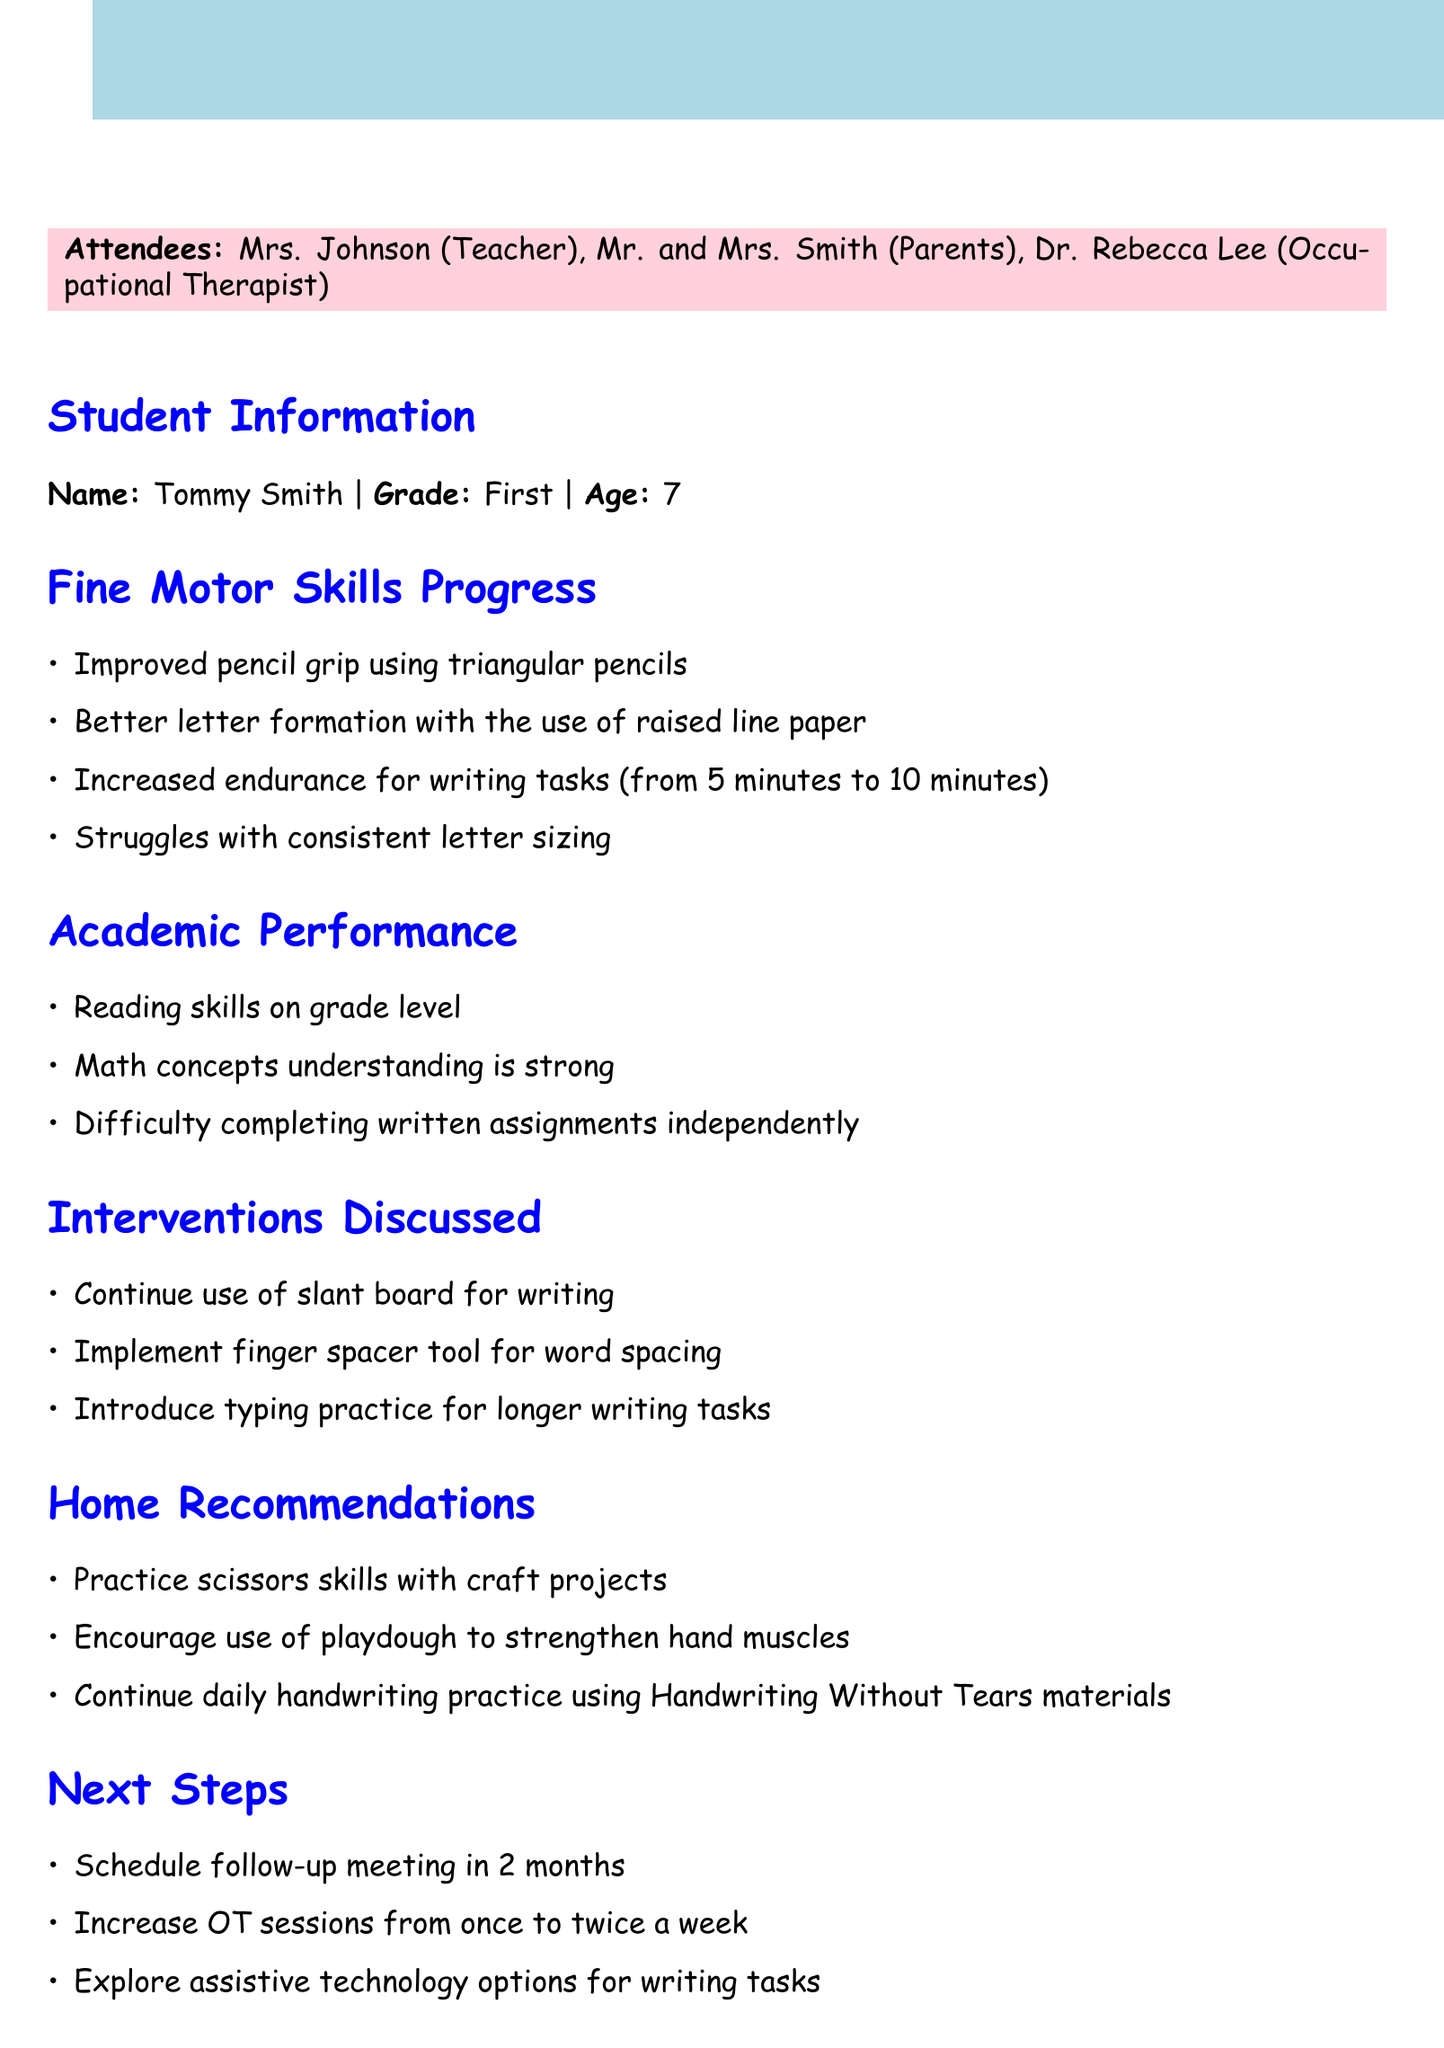What is the date of the meeting? The date of the meeting is stated in the document.
Answer: May 15, 2023 Who is the teacher attending the meeting? The document lists the attendees, including the teacher.
Answer: Mrs. Johnson How long can Tommy write now? The document states Tommy's increased endurance for writing tasks.
Answer: 10 minutes What is one of the home recommendations? The document provides recommendations for home activities.
Answer: Practice scissors skills with craft projects What will happen in 2 months? The document outlines next steps, including scheduling a follow-up meeting.
Answer: Schedule follow-up meeting What is Tommy's performance in reading? The document summarizes Tommy's academic performance, specifically in reading.
Answer: On grade level What tool will be implemented for word spacing? The document mentions specific interventions discussed during the meeting.
Answer: Finger spacer tool How many times a week will OT sessions increase? The document details the adjustments to occupational therapy sessions.
Answer: Twice a week 